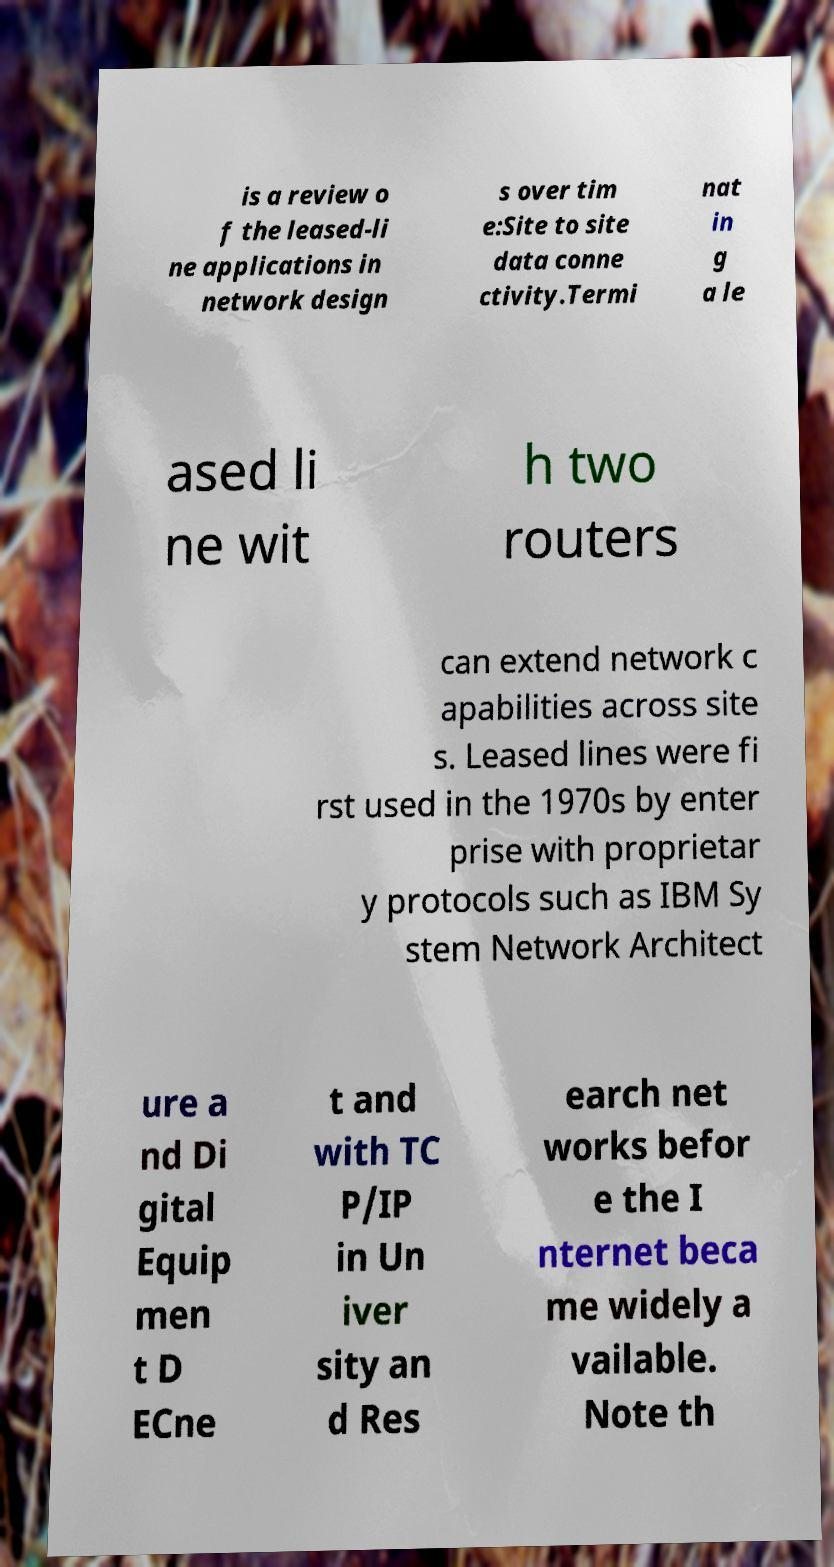Please identify and transcribe the text found in this image. is a review o f the leased-li ne applications in network design s over tim e:Site to site data conne ctivity.Termi nat in g a le ased li ne wit h two routers can extend network c apabilities across site s. Leased lines were fi rst used in the 1970s by enter prise with proprietar y protocols such as IBM Sy stem Network Architect ure a nd Di gital Equip men t D ECne t and with TC P/IP in Un iver sity an d Res earch net works befor e the I nternet beca me widely a vailable. Note th 